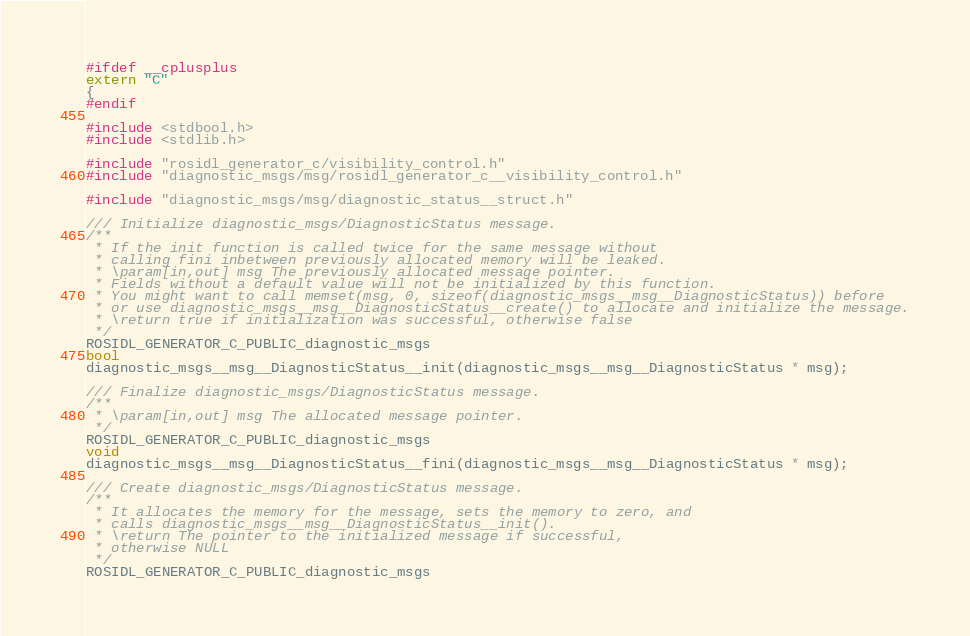<code> <loc_0><loc_0><loc_500><loc_500><_C_>
#ifdef __cplusplus
extern "C"
{
#endif

#include <stdbool.h>
#include <stdlib.h>

#include "rosidl_generator_c/visibility_control.h"
#include "diagnostic_msgs/msg/rosidl_generator_c__visibility_control.h"

#include "diagnostic_msgs/msg/diagnostic_status__struct.h"

/// Initialize diagnostic_msgs/DiagnosticStatus message.
/**
 * If the init function is called twice for the same message without
 * calling fini inbetween previously allocated memory will be leaked.
 * \param[in,out] msg The previously allocated message pointer.
 * Fields without a default value will not be initialized by this function.
 * You might want to call memset(msg, 0, sizeof(diagnostic_msgs__msg__DiagnosticStatus)) before
 * or use diagnostic_msgs__msg__DiagnosticStatus__create() to allocate and initialize the message.
 * \return true if initialization was successful, otherwise false
 */
ROSIDL_GENERATOR_C_PUBLIC_diagnostic_msgs
bool
diagnostic_msgs__msg__DiagnosticStatus__init(diagnostic_msgs__msg__DiagnosticStatus * msg);

/// Finalize diagnostic_msgs/DiagnosticStatus message.
/**
 * \param[in,out] msg The allocated message pointer.
 */
ROSIDL_GENERATOR_C_PUBLIC_diagnostic_msgs
void
diagnostic_msgs__msg__DiagnosticStatus__fini(diagnostic_msgs__msg__DiagnosticStatus * msg);

/// Create diagnostic_msgs/DiagnosticStatus message.
/**
 * It allocates the memory for the message, sets the memory to zero, and
 * calls diagnostic_msgs__msg__DiagnosticStatus__init().
 * \return The pointer to the initialized message if successful,
 * otherwise NULL
 */
ROSIDL_GENERATOR_C_PUBLIC_diagnostic_msgs</code> 